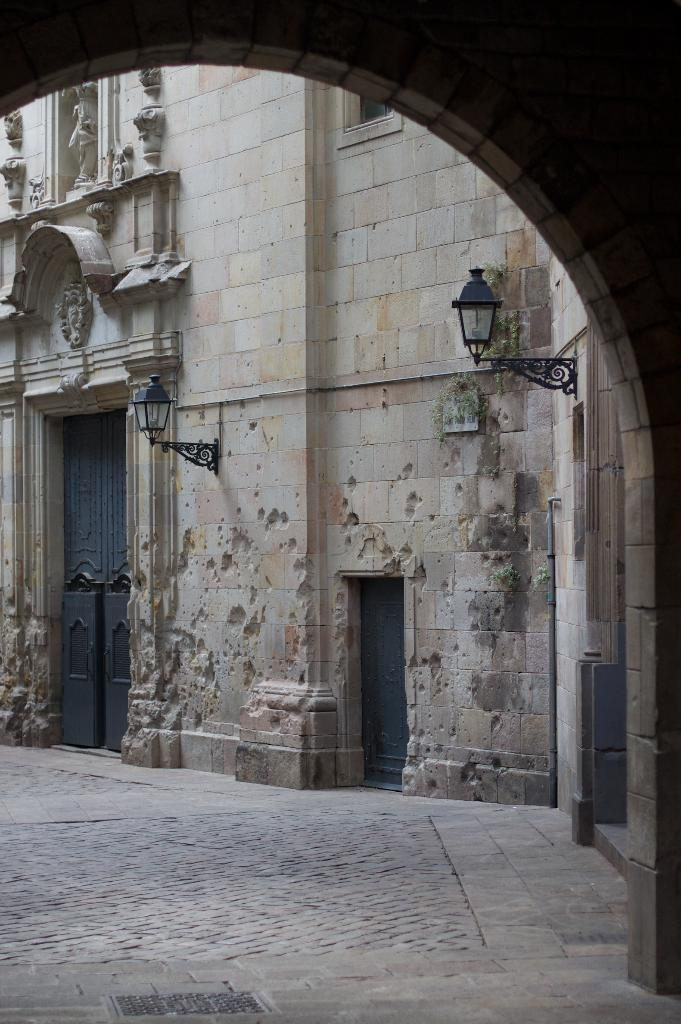What is the main structure in the center of the image? There is a building in the center of the image. What features can be seen on the building? The building has doors and lights. What is located in the foreground of the image? There is a wall in the foreground of the image. What is visible at the bottom of the image? There is a road at the bottom of the image. Is there a prison visible in the image? There is no prison present in the image. Can you see a volcano erupting in the background of the image? There is no volcano present in the image. 